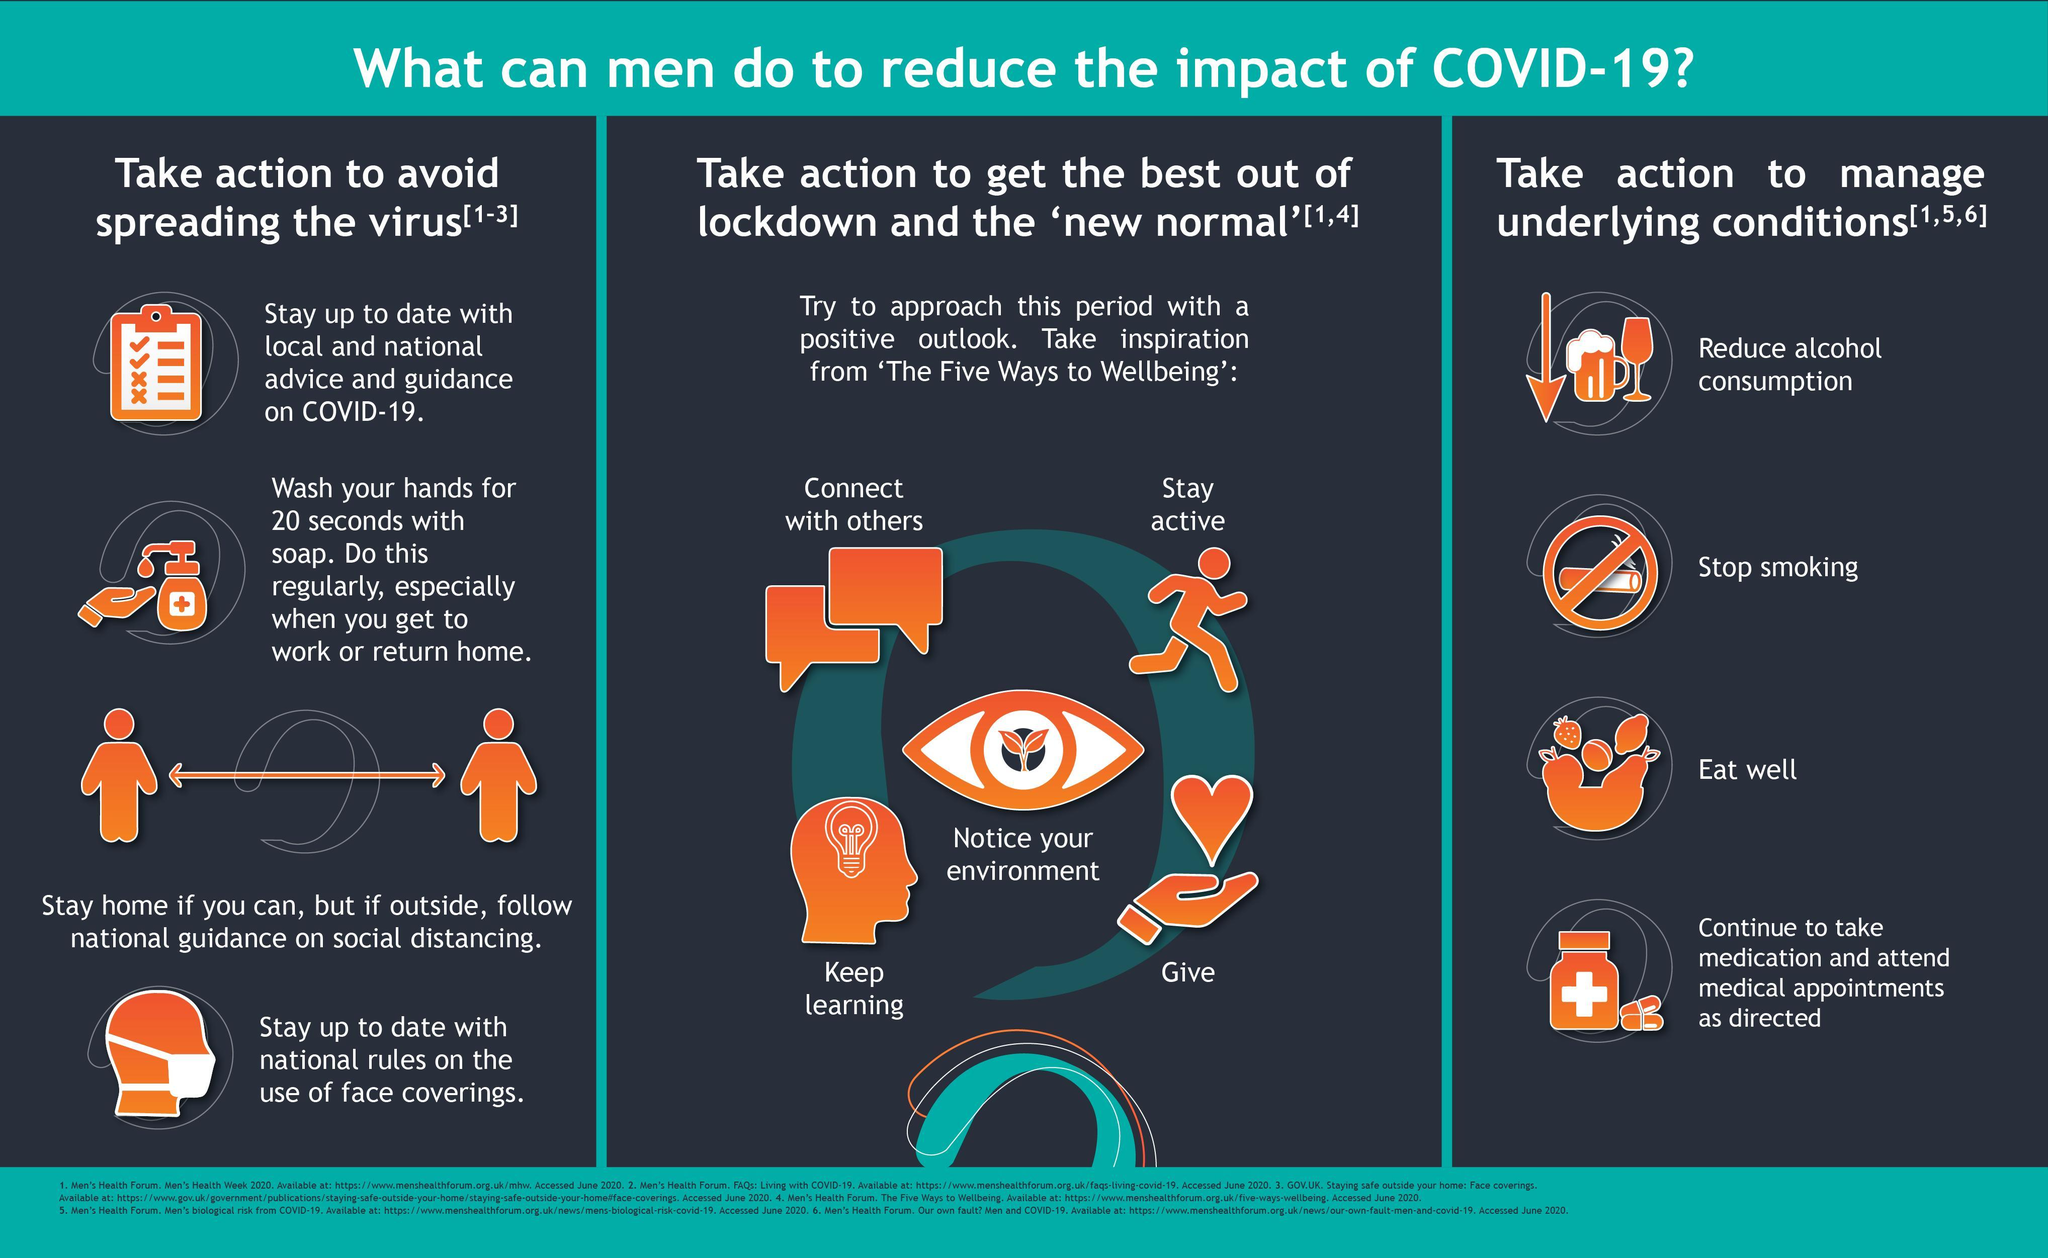what is the need to be connected with others
Answer the question with a short phrase. to get the best out of lockdwon and the 'new normal' Stop smoking comes under which action point to manage underlying conditions why is social distancing important to avoid spreading the virus To stay active comes under which action point to get the best out of lockdwon and the 'new normal' 